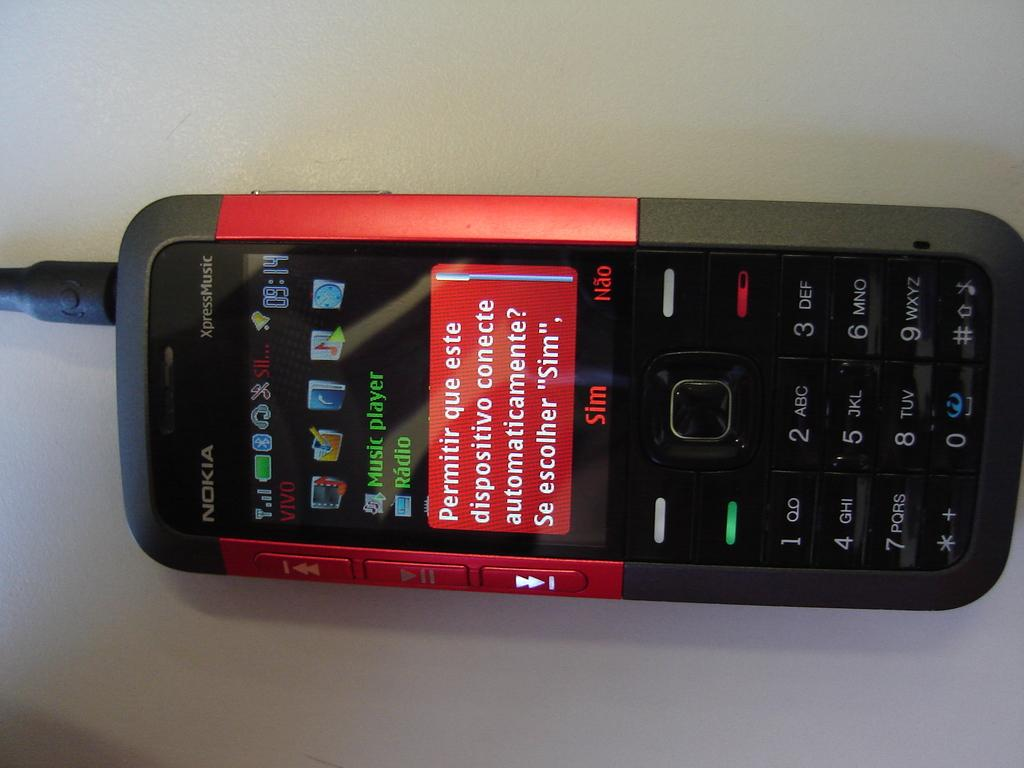<image>
Give a short and clear explanation of the subsequent image. a nokia phone with a spanish warning asking to connect automatically 